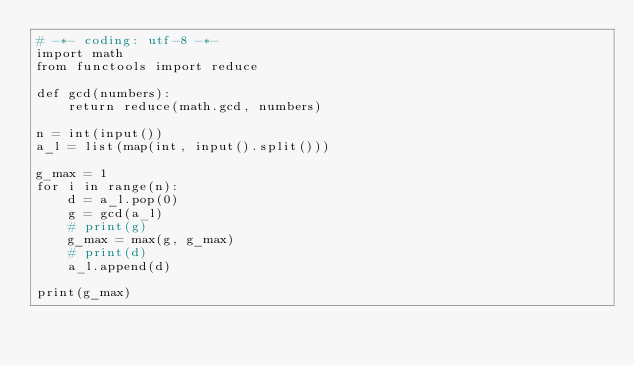<code> <loc_0><loc_0><loc_500><loc_500><_Python_># -*- coding: utf-8 -*-
import math
from functools import reduce

def gcd(numbers):
    return reduce(math.gcd, numbers)

n = int(input())
a_l = list(map(int, input().split()))

g_max = 1
for i in range(n):
    d = a_l.pop(0)
    g = gcd(a_l)
    # print(g)
    g_max = max(g, g_max)
    # print(d)
    a_l.append(d)

print(g_max)</code> 